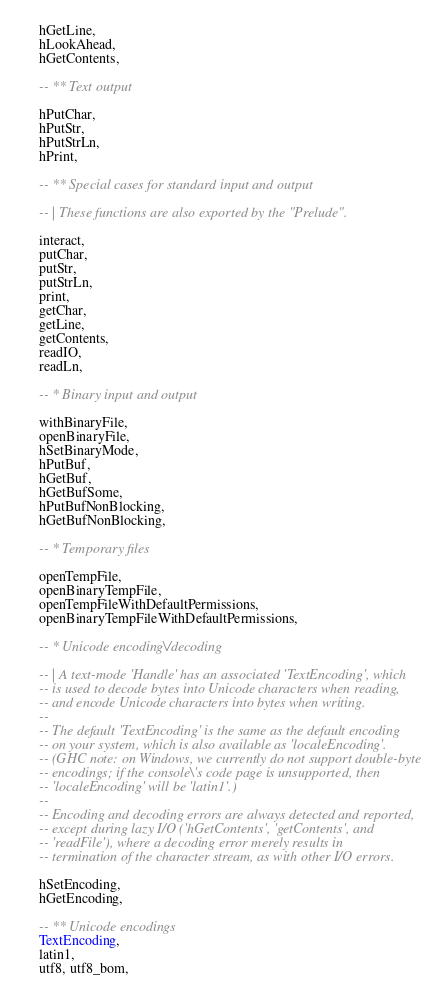<code> <loc_0><loc_0><loc_500><loc_500><_Haskell_>    hGetLine,
    hLookAhead,
    hGetContents,

    -- ** Text output

    hPutChar,
    hPutStr,
    hPutStrLn,
    hPrint,

    -- ** Special cases for standard input and output

    -- | These functions are also exported by the "Prelude".

    interact,
    putChar,
    putStr,
    putStrLn,
    print,
    getChar,
    getLine,
    getContents,
    readIO,
    readLn,

    -- * Binary input and output

    withBinaryFile,
    openBinaryFile,
    hSetBinaryMode,
    hPutBuf,
    hGetBuf,
    hGetBufSome,
    hPutBufNonBlocking,
    hGetBufNonBlocking,

    -- * Temporary files

    openTempFile,
    openBinaryTempFile,
    openTempFileWithDefaultPermissions,
    openBinaryTempFileWithDefaultPermissions,

    -- * Unicode encoding\/decoding

    -- | A text-mode 'Handle' has an associated 'TextEncoding', which
    -- is used to decode bytes into Unicode characters when reading,
    -- and encode Unicode characters into bytes when writing.
    --
    -- The default 'TextEncoding' is the same as the default encoding
    -- on your system, which is also available as 'localeEncoding'.
    -- (GHC note: on Windows, we currently do not support double-byte
    -- encodings; if the console\'s code page is unsupported, then
    -- 'localeEncoding' will be 'latin1'.)
    --
    -- Encoding and decoding errors are always detected and reported,
    -- except during lazy I/O ('hGetContents', 'getContents', and
    -- 'readFile'), where a decoding error merely results in
    -- termination of the character stream, as with other I/O errors.

    hSetEncoding,
    hGetEncoding,

    -- ** Unicode encodings
    TextEncoding,
    latin1,
    utf8, utf8_bom,</code> 